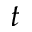<formula> <loc_0><loc_0><loc_500><loc_500>t</formula> 